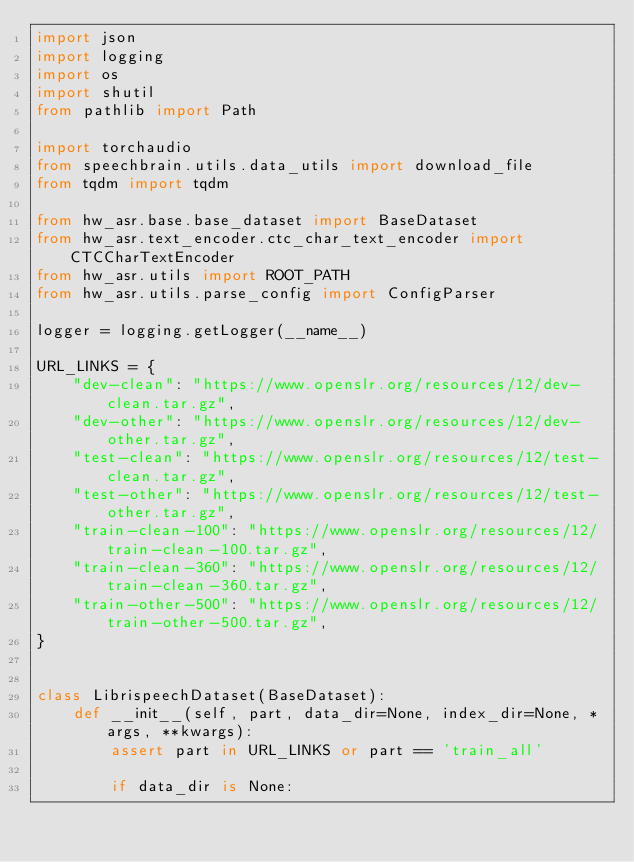Convert code to text. <code><loc_0><loc_0><loc_500><loc_500><_Python_>import json
import logging
import os
import shutil
from pathlib import Path

import torchaudio
from speechbrain.utils.data_utils import download_file
from tqdm import tqdm

from hw_asr.base.base_dataset import BaseDataset
from hw_asr.text_encoder.ctc_char_text_encoder import CTCCharTextEncoder
from hw_asr.utils import ROOT_PATH
from hw_asr.utils.parse_config import ConfigParser

logger = logging.getLogger(__name__)

URL_LINKS = {
    "dev-clean": "https://www.openslr.org/resources/12/dev-clean.tar.gz",
    "dev-other": "https://www.openslr.org/resources/12/dev-other.tar.gz",
    "test-clean": "https://www.openslr.org/resources/12/test-clean.tar.gz",
    "test-other": "https://www.openslr.org/resources/12/test-other.tar.gz",
    "train-clean-100": "https://www.openslr.org/resources/12/train-clean-100.tar.gz",
    "train-clean-360": "https://www.openslr.org/resources/12/train-clean-360.tar.gz",
    "train-other-500": "https://www.openslr.org/resources/12/train-other-500.tar.gz",
}


class LibrispeechDataset(BaseDataset):
    def __init__(self, part, data_dir=None, index_dir=None, *args, **kwargs):
        assert part in URL_LINKS or part == 'train_all'

        if data_dir is None:</code> 